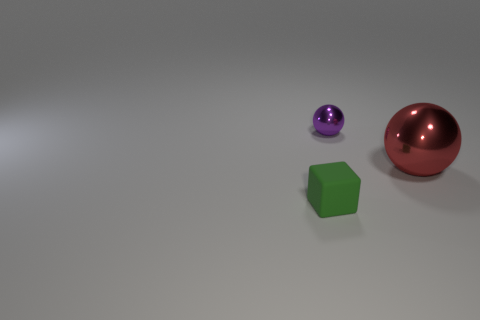Add 1 small yellow rubber cubes. How many objects exist? 4 Subtract all spheres. How many objects are left? 1 Subtract 1 red balls. How many objects are left? 2 Subtract all big blue spheres. Subtract all green rubber objects. How many objects are left? 2 Add 3 big red metal things. How many big red metal things are left? 4 Add 1 large blue spheres. How many large blue spheres exist? 1 